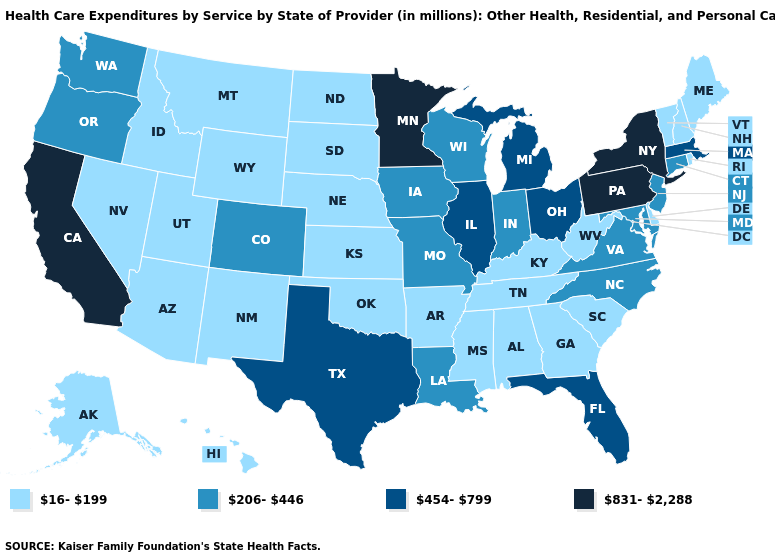Does Vermont have the lowest value in the Northeast?
Keep it brief. Yes. Which states hav the highest value in the MidWest?
Give a very brief answer. Minnesota. What is the value of Wisconsin?
Give a very brief answer. 206-446. Does Indiana have a higher value than North Dakota?
Short answer required. Yes. Among the states that border Pennsylvania , which have the lowest value?
Keep it brief. Delaware, West Virginia. Among the states that border Delaware , which have the lowest value?
Be succinct. Maryland, New Jersey. What is the value of Arizona?
Write a very short answer. 16-199. What is the highest value in the USA?
Short answer required. 831-2,288. Name the states that have a value in the range 206-446?
Concise answer only. Colorado, Connecticut, Indiana, Iowa, Louisiana, Maryland, Missouri, New Jersey, North Carolina, Oregon, Virginia, Washington, Wisconsin. What is the value of Arizona?
Keep it brief. 16-199. Does Ohio have the highest value in the MidWest?
Short answer required. No. What is the highest value in states that border North Dakota?
Keep it brief. 831-2,288. How many symbols are there in the legend?
Short answer required. 4. Name the states that have a value in the range 16-199?
Keep it brief. Alabama, Alaska, Arizona, Arkansas, Delaware, Georgia, Hawaii, Idaho, Kansas, Kentucky, Maine, Mississippi, Montana, Nebraska, Nevada, New Hampshire, New Mexico, North Dakota, Oklahoma, Rhode Island, South Carolina, South Dakota, Tennessee, Utah, Vermont, West Virginia, Wyoming. Name the states that have a value in the range 16-199?
Concise answer only. Alabama, Alaska, Arizona, Arkansas, Delaware, Georgia, Hawaii, Idaho, Kansas, Kentucky, Maine, Mississippi, Montana, Nebraska, Nevada, New Hampshire, New Mexico, North Dakota, Oklahoma, Rhode Island, South Carolina, South Dakota, Tennessee, Utah, Vermont, West Virginia, Wyoming. 